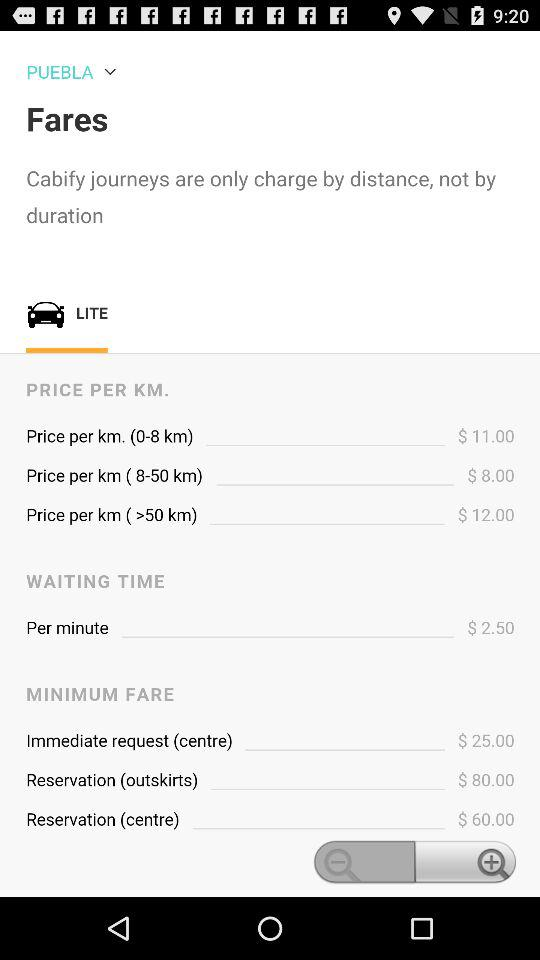What is the minimum fare for reservation (centre)? The minimum fare for reservation (centre) is $60. 